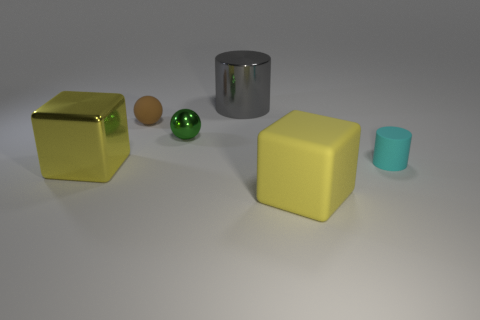Add 3 large rubber cubes. How many objects exist? 9 Subtract all spheres. How many objects are left? 4 Subtract all yellow cubes. Subtract all large gray metallic spheres. How many objects are left? 4 Add 4 big metallic cubes. How many big metallic cubes are left? 5 Add 6 yellow metallic blocks. How many yellow metallic blocks exist? 7 Subtract 2 yellow blocks. How many objects are left? 4 